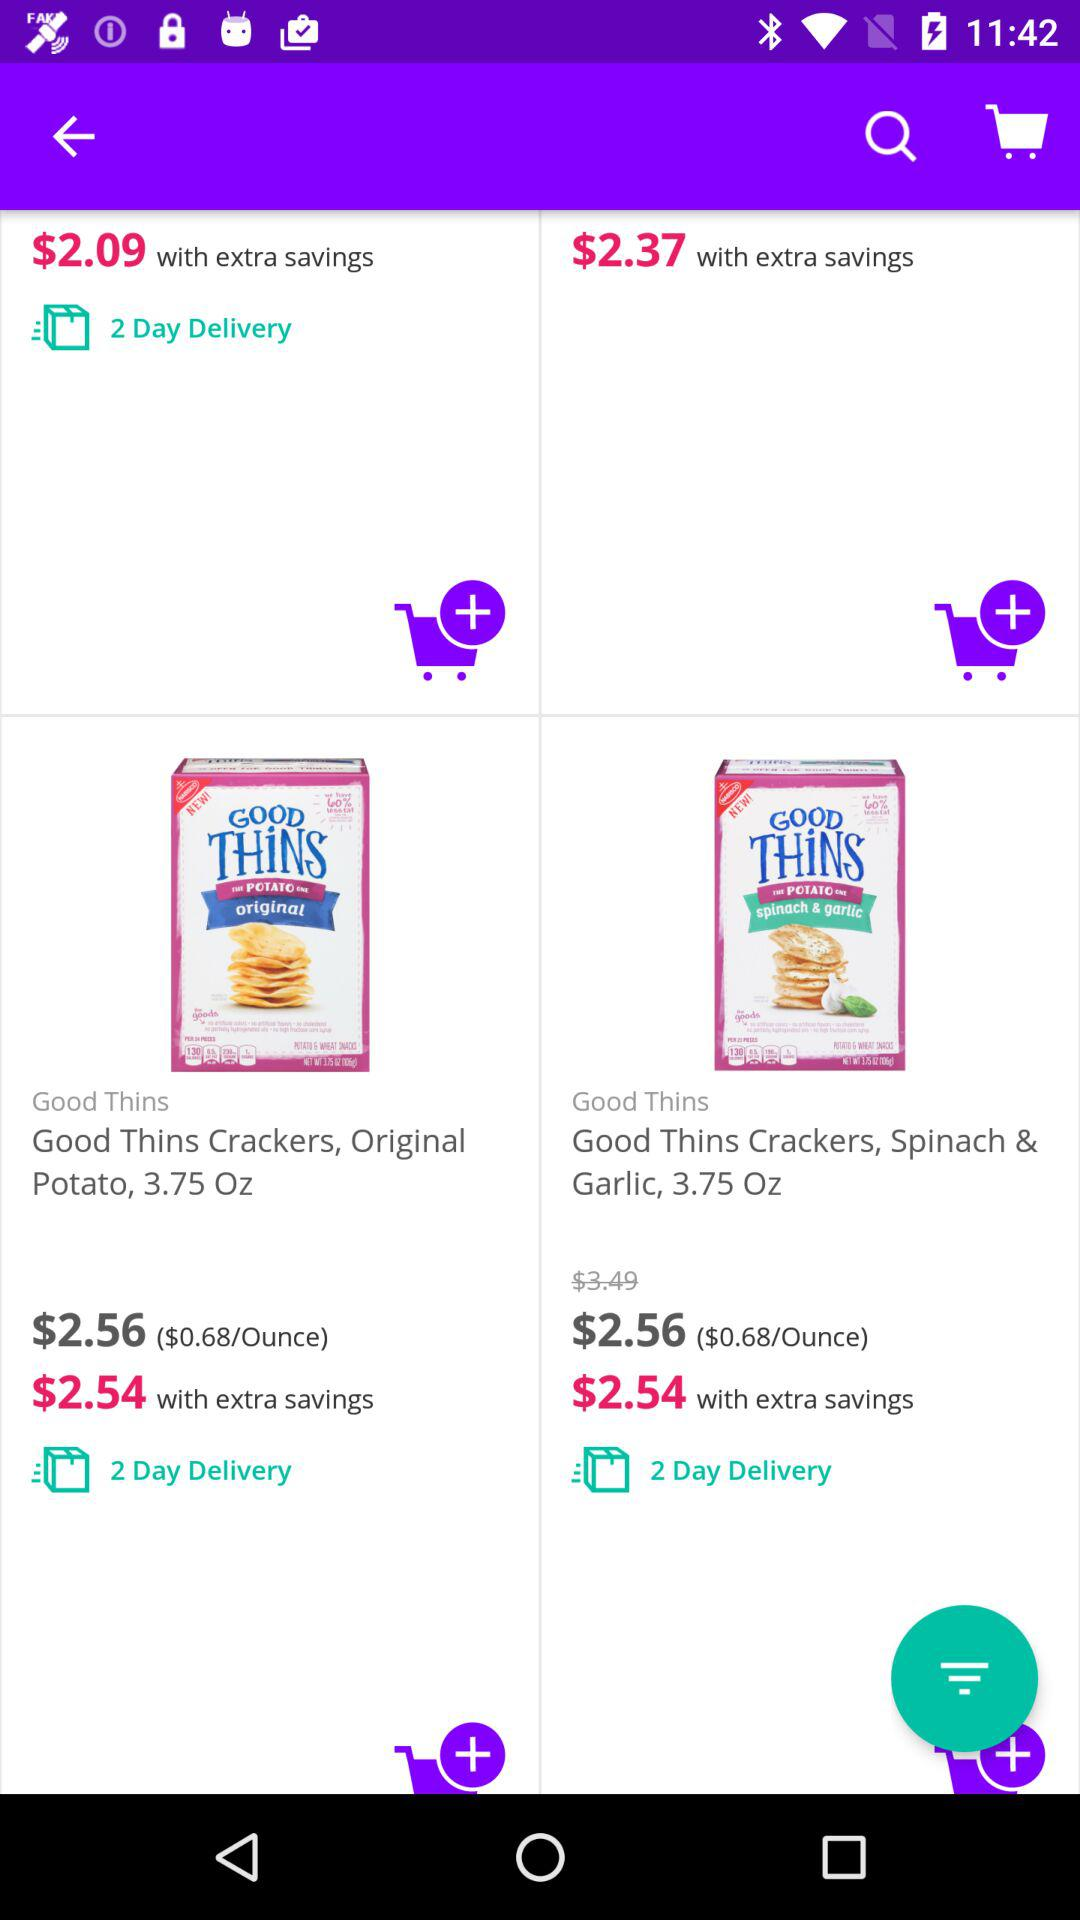How many days will it take to deliver? It will take 2 days to deliver. 